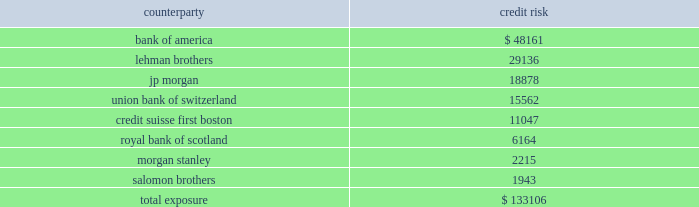Mortgage banking activities the company enters into commitments to originate loans whereby the interest rate on the loan is determined prior to funding .
These commitments are referred to as interest rate lock commitments ( 201cirlcs 201d ) .
Irlcs on loans that the company intends to sell are considered to be derivatives and are , therefore , recorded at fair value with changes in fair value recorded in earnings .
For purposes of determining fair value , the company estimates the fair value of an irlc based on the estimated fair value of the underlying mortgage loan and the probability that the mortgage loan will fund within the terms of the irlc .
The fair value excludes the market value associated with the anticipated sale of servicing rights related to each loan commitment .
The fair value of these irlcs was a $ 0.06 million and a $ 0.02 million liability at december 31 , 2007 and 2006 , respectively .
The company also designates fair value relationships of closed loans held-for-sale against a combination of mortgage forwards and short treasury positions .
Short treasury relationships are economic hedges , rather than fair value or cash flow hedges .
Short treasury positions are marked-to-market , but do not receive hedge accounting treatment under sfas no .
133 , as amended .
The mark-to-market of the mortgage forwards is included in the net change of the irlcs and the related hedging instruments .
The fair value of the mark-to-market on closed loans was a $ 1.2 thousand and $ 1.7 million asset at december 31 , 2007 and 2006 , respectively .
Irlcs , as well as closed loans held-for-sale , expose the company to interest rate risk .
The company manages this risk by selling mortgages or mortgage-backed securities on a forward basis referred to as forward sale agreements .
Changes in the fair value of these derivatives are included as gain ( loss ) on loans and securities , net in the consolidated statement of income ( loss ) .
The net change in irlcs , closed loans , mortgage forwards and the short treasury positions generated a net loss of $ 2.4 million in 2007 , a net gain of $ 1.6 million in 2006 and a net loss of $ 0.4 million in 2005 .
Credit risk credit risk is managed by limiting activity to approved counterparties and setting aggregate exposure limits for each approved counterparty .
The credit risk , or maximum exposure , which results from interest rate swaps and purchased interest rate options is represented by the fair value of contracts that have unrealized gains at the reporting date .
Conversely , we have $ 197.5 million of derivative contracts with unrealized losses at december 31 , 2007 .
The company pledged approximately $ 87.4 million of its mortgage-backed securities as collateral of derivative contracts .
While the company does not expect that any counterparty will fail to perform , the table shows the maximum exposure associated with each counterparty to interest rate swaps and purchased interest rate options at december 31 , 2007 ( dollars in thousands ) : counterparty credit .

What percentage of counterparty exposure at december 31 2007 is represented by lehman brothers? 
Computations: (29136 / 133106)
Answer: 0.21889. 